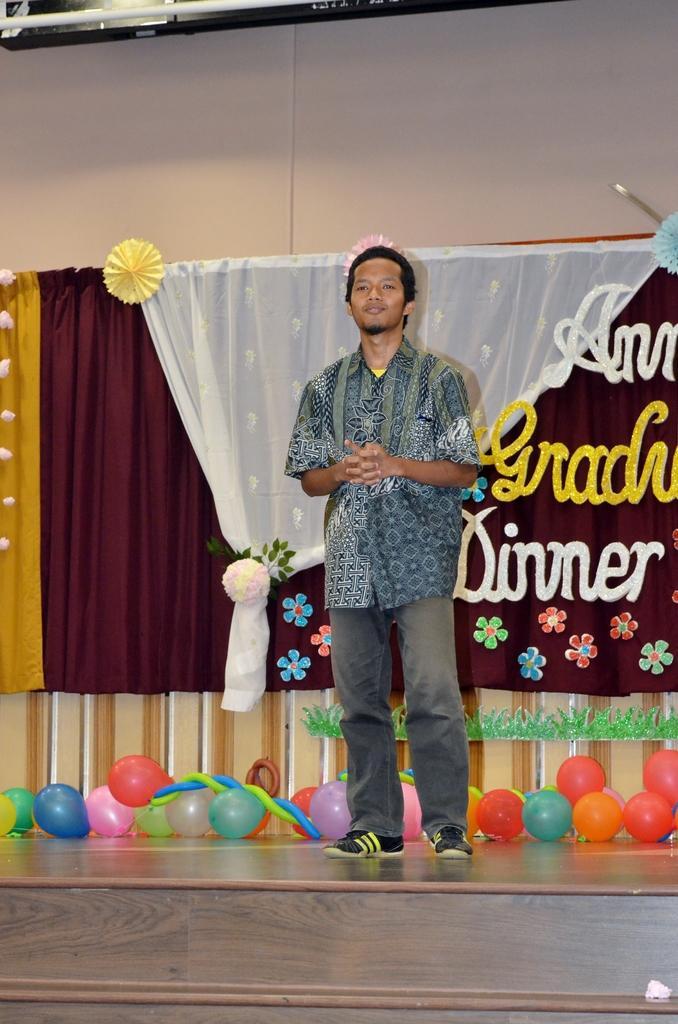Describe this image in one or two sentences. In the center of the picture there is a stage, on the stage there are balloons, curtains, thermocol sheets, decorative items and a person standing. At the top it is wall and there is another object. 